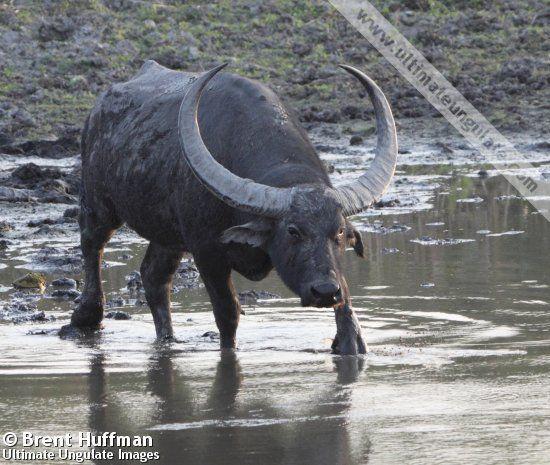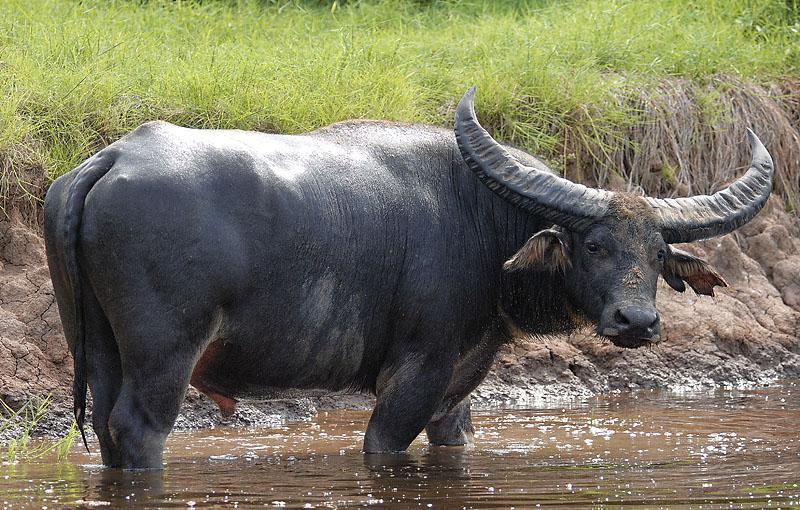The first image is the image on the left, the second image is the image on the right. For the images displayed, is the sentence "The animal in the image on the right is standing in side profile with its head turned toward the camera." factually correct? Answer yes or no. Yes. 